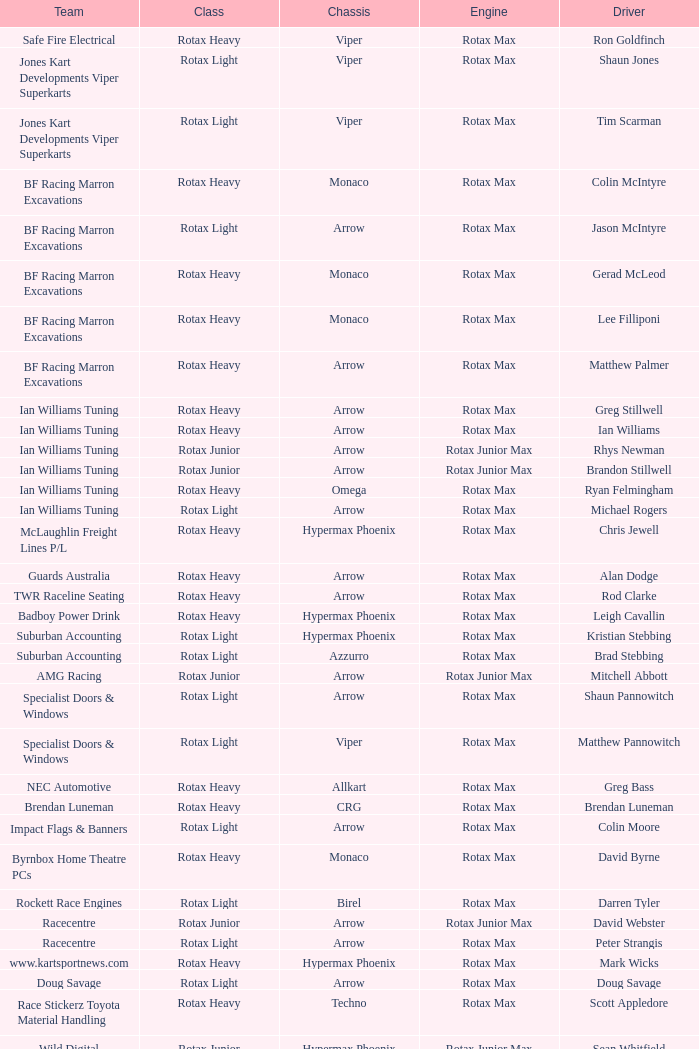What type of engine does the BF Racing Marron Excavations have that also has Monaco as chassis and Lee Filliponi as the driver? Rotax Max. 